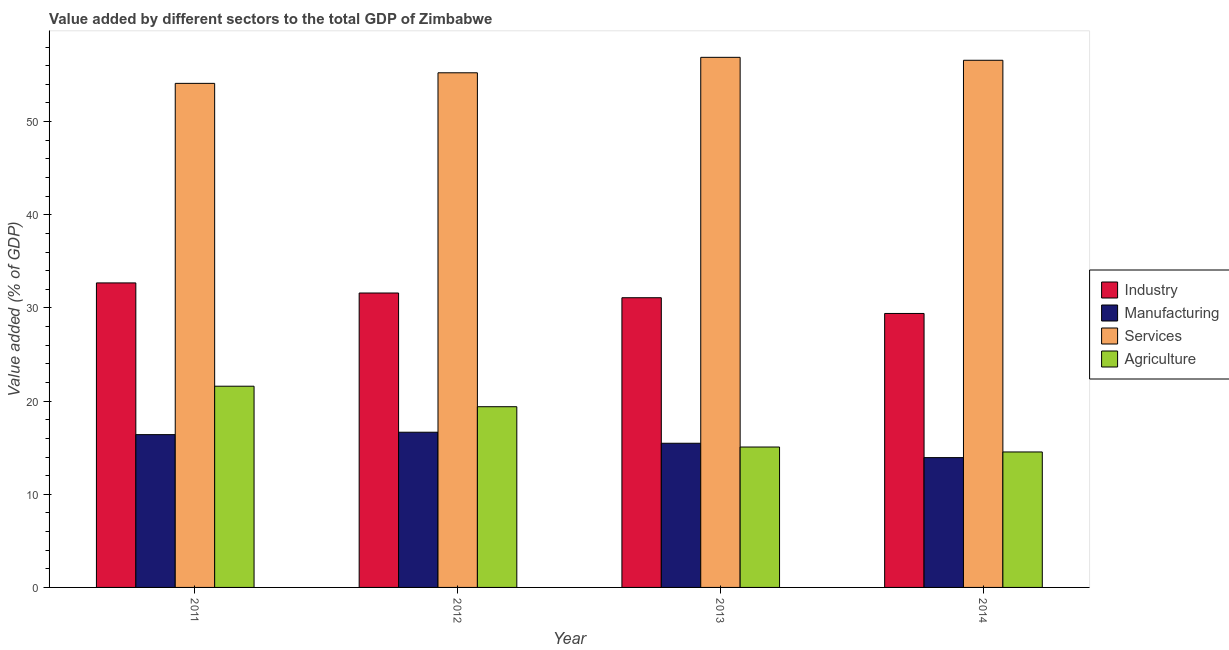How many different coloured bars are there?
Your answer should be very brief. 4. How many groups of bars are there?
Your answer should be compact. 4. Are the number of bars per tick equal to the number of legend labels?
Your answer should be compact. Yes. How many bars are there on the 1st tick from the left?
Ensure brevity in your answer.  4. How many bars are there on the 1st tick from the right?
Make the answer very short. 4. What is the label of the 1st group of bars from the left?
Make the answer very short. 2011. What is the value added by manufacturing sector in 2011?
Your answer should be very brief. 16.4. Across all years, what is the maximum value added by manufacturing sector?
Offer a very short reply. 16.66. Across all years, what is the minimum value added by manufacturing sector?
Provide a short and direct response. 13.93. In which year was the value added by manufacturing sector maximum?
Your response must be concise. 2012. In which year was the value added by services sector minimum?
Your answer should be very brief. 2011. What is the total value added by agricultural sector in the graph?
Provide a short and direct response. 70.61. What is the difference between the value added by industrial sector in 2012 and that in 2013?
Keep it short and to the point. 0.51. What is the difference between the value added by manufacturing sector in 2014 and the value added by agricultural sector in 2011?
Give a very brief answer. -2.47. What is the average value added by agricultural sector per year?
Provide a succinct answer. 17.65. In the year 2013, what is the difference between the value added by services sector and value added by manufacturing sector?
Your response must be concise. 0. What is the ratio of the value added by manufacturing sector in 2011 to that in 2013?
Provide a succinct answer. 1.06. Is the value added by services sector in 2011 less than that in 2013?
Make the answer very short. Yes. Is the difference between the value added by industrial sector in 2012 and 2014 greater than the difference between the value added by services sector in 2012 and 2014?
Provide a short and direct response. No. What is the difference between the highest and the second highest value added by industrial sector?
Your answer should be very brief. 1.08. What is the difference between the highest and the lowest value added by manufacturing sector?
Your answer should be compact. 2.73. What does the 2nd bar from the left in 2011 represents?
Provide a succinct answer. Manufacturing. What does the 4th bar from the right in 2012 represents?
Your response must be concise. Industry. Is it the case that in every year, the sum of the value added by industrial sector and value added by manufacturing sector is greater than the value added by services sector?
Give a very brief answer. No. Are the values on the major ticks of Y-axis written in scientific E-notation?
Keep it short and to the point. No. Where does the legend appear in the graph?
Offer a very short reply. Center right. How many legend labels are there?
Ensure brevity in your answer.  4. What is the title of the graph?
Give a very brief answer. Value added by different sectors to the total GDP of Zimbabwe. Does "Custom duties" appear as one of the legend labels in the graph?
Your response must be concise. No. What is the label or title of the Y-axis?
Provide a succinct answer. Value added (% of GDP). What is the Value added (% of GDP) in Industry in 2011?
Offer a terse response. 32.69. What is the Value added (% of GDP) of Manufacturing in 2011?
Provide a succinct answer. 16.4. What is the Value added (% of GDP) of Services in 2011?
Provide a short and direct response. 54.11. What is the Value added (% of GDP) in Agriculture in 2011?
Make the answer very short. 21.6. What is the Value added (% of GDP) in Industry in 2012?
Provide a succinct answer. 31.6. What is the Value added (% of GDP) of Manufacturing in 2012?
Your answer should be compact. 16.66. What is the Value added (% of GDP) in Services in 2012?
Ensure brevity in your answer.  55.24. What is the Value added (% of GDP) in Agriculture in 2012?
Offer a terse response. 19.4. What is the Value added (% of GDP) in Industry in 2013?
Keep it short and to the point. 31.1. What is the Value added (% of GDP) of Manufacturing in 2013?
Give a very brief answer. 15.48. What is the Value added (% of GDP) of Services in 2013?
Your response must be concise. 56.9. What is the Value added (% of GDP) of Agriculture in 2013?
Offer a very short reply. 15.07. What is the Value added (% of GDP) in Industry in 2014?
Keep it short and to the point. 29.41. What is the Value added (% of GDP) in Manufacturing in 2014?
Offer a very short reply. 13.93. What is the Value added (% of GDP) of Services in 2014?
Make the answer very short. 56.59. What is the Value added (% of GDP) of Agriculture in 2014?
Make the answer very short. 14.54. Across all years, what is the maximum Value added (% of GDP) in Industry?
Your answer should be compact. 32.69. Across all years, what is the maximum Value added (% of GDP) of Manufacturing?
Your response must be concise. 16.66. Across all years, what is the maximum Value added (% of GDP) of Services?
Give a very brief answer. 56.9. Across all years, what is the maximum Value added (% of GDP) in Agriculture?
Make the answer very short. 21.6. Across all years, what is the minimum Value added (% of GDP) of Industry?
Offer a very short reply. 29.41. Across all years, what is the minimum Value added (% of GDP) of Manufacturing?
Offer a terse response. 13.93. Across all years, what is the minimum Value added (% of GDP) in Services?
Offer a terse response. 54.11. Across all years, what is the minimum Value added (% of GDP) of Agriculture?
Your response must be concise. 14.54. What is the total Value added (% of GDP) in Industry in the graph?
Provide a succinct answer. 124.79. What is the total Value added (% of GDP) in Manufacturing in the graph?
Provide a succinct answer. 62.47. What is the total Value added (% of GDP) in Services in the graph?
Ensure brevity in your answer.  222.84. What is the total Value added (% of GDP) in Agriculture in the graph?
Ensure brevity in your answer.  70.61. What is the difference between the Value added (% of GDP) in Industry in 2011 and that in 2012?
Your response must be concise. 1.08. What is the difference between the Value added (% of GDP) of Manufacturing in 2011 and that in 2012?
Your response must be concise. -0.26. What is the difference between the Value added (% of GDP) in Services in 2011 and that in 2012?
Give a very brief answer. -1.13. What is the difference between the Value added (% of GDP) in Agriculture in 2011 and that in 2012?
Your response must be concise. 2.2. What is the difference between the Value added (% of GDP) of Industry in 2011 and that in 2013?
Give a very brief answer. 1.59. What is the difference between the Value added (% of GDP) in Manufacturing in 2011 and that in 2013?
Offer a very short reply. 0.93. What is the difference between the Value added (% of GDP) in Services in 2011 and that in 2013?
Your response must be concise. -2.79. What is the difference between the Value added (% of GDP) in Agriculture in 2011 and that in 2013?
Ensure brevity in your answer.  6.53. What is the difference between the Value added (% of GDP) of Industry in 2011 and that in 2014?
Your response must be concise. 3.28. What is the difference between the Value added (% of GDP) of Manufacturing in 2011 and that in 2014?
Ensure brevity in your answer.  2.47. What is the difference between the Value added (% of GDP) of Services in 2011 and that in 2014?
Offer a very short reply. -2.48. What is the difference between the Value added (% of GDP) of Agriculture in 2011 and that in 2014?
Make the answer very short. 7.06. What is the difference between the Value added (% of GDP) in Industry in 2012 and that in 2013?
Your answer should be very brief. 0.51. What is the difference between the Value added (% of GDP) of Manufacturing in 2012 and that in 2013?
Your answer should be compact. 1.18. What is the difference between the Value added (% of GDP) in Services in 2012 and that in 2013?
Your answer should be very brief. -1.66. What is the difference between the Value added (% of GDP) in Agriculture in 2012 and that in 2013?
Provide a succinct answer. 4.33. What is the difference between the Value added (% of GDP) in Industry in 2012 and that in 2014?
Your answer should be compact. 2.2. What is the difference between the Value added (% of GDP) in Manufacturing in 2012 and that in 2014?
Your answer should be very brief. 2.73. What is the difference between the Value added (% of GDP) of Services in 2012 and that in 2014?
Make the answer very short. -1.34. What is the difference between the Value added (% of GDP) in Agriculture in 2012 and that in 2014?
Provide a short and direct response. 4.86. What is the difference between the Value added (% of GDP) in Industry in 2013 and that in 2014?
Provide a short and direct response. 1.69. What is the difference between the Value added (% of GDP) of Manufacturing in 2013 and that in 2014?
Give a very brief answer. 1.54. What is the difference between the Value added (% of GDP) of Services in 2013 and that in 2014?
Offer a terse response. 0.32. What is the difference between the Value added (% of GDP) of Agriculture in 2013 and that in 2014?
Offer a terse response. 0.53. What is the difference between the Value added (% of GDP) of Industry in 2011 and the Value added (% of GDP) of Manufacturing in 2012?
Offer a very short reply. 16.03. What is the difference between the Value added (% of GDP) of Industry in 2011 and the Value added (% of GDP) of Services in 2012?
Keep it short and to the point. -22.56. What is the difference between the Value added (% of GDP) of Industry in 2011 and the Value added (% of GDP) of Agriculture in 2012?
Offer a very short reply. 13.29. What is the difference between the Value added (% of GDP) in Manufacturing in 2011 and the Value added (% of GDP) in Services in 2012?
Your answer should be very brief. -38.84. What is the difference between the Value added (% of GDP) of Manufacturing in 2011 and the Value added (% of GDP) of Agriculture in 2012?
Give a very brief answer. -3. What is the difference between the Value added (% of GDP) of Services in 2011 and the Value added (% of GDP) of Agriculture in 2012?
Keep it short and to the point. 34.71. What is the difference between the Value added (% of GDP) in Industry in 2011 and the Value added (% of GDP) in Manufacturing in 2013?
Offer a terse response. 17.21. What is the difference between the Value added (% of GDP) in Industry in 2011 and the Value added (% of GDP) in Services in 2013?
Provide a succinct answer. -24.21. What is the difference between the Value added (% of GDP) in Industry in 2011 and the Value added (% of GDP) in Agriculture in 2013?
Make the answer very short. 17.61. What is the difference between the Value added (% of GDP) in Manufacturing in 2011 and the Value added (% of GDP) in Services in 2013?
Offer a very short reply. -40.5. What is the difference between the Value added (% of GDP) of Manufacturing in 2011 and the Value added (% of GDP) of Agriculture in 2013?
Provide a succinct answer. 1.33. What is the difference between the Value added (% of GDP) of Services in 2011 and the Value added (% of GDP) of Agriculture in 2013?
Your answer should be compact. 39.04. What is the difference between the Value added (% of GDP) in Industry in 2011 and the Value added (% of GDP) in Manufacturing in 2014?
Your answer should be very brief. 18.75. What is the difference between the Value added (% of GDP) of Industry in 2011 and the Value added (% of GDP) of Services in 2014?
Your answer should be compact. -23.9. What is the difference between the Value added (% of GDP) in Industry in 2011 and the Value added (% of GDP) in Agriculture in 2014?
Your answer should be very brief. 18.15. What is the difference between the Value added (% of GDP) in Manufacturing in 2011 and the Value added (% of GDP) in Services in 2014?
Ensure brevity in your answer.  -40.18. What is the difference between the Value added (% of GDP) of Manufacturing in 2011 and the Value added (% of GDP) of Agriculture in 2014?
Provide a succinct answer. 1.86. What is the difference between the Value added (% of GDP) in Services in 2011 and the Value added (% of GDP) in Agriculture in 2014?
Keep it short and to the point. 39.57. What is the difference between the Value added (% of GDP) in Industry in 2012 and the Value added (% of GDP) in Manufacturing in 2013?
Ensure brevity in your answer.  16.13. What is the difference between the Value added (% of GDP) of Industry in 2012 and the Value added (% of GDP) of Services in 2013?
Offer a very short reply. -25.3. What is the difference between the Value added (% of GDP) in Industry in 2012 and the Value added (% of GDP) in Agriculture in 2013?
Provide a short and direct response. 16.53. What is the difference between the Value added (% of GDP) in Manufacturing in 2012 and the Value added (% of GDP) in Services in 2013?
Your answer should be compact. -40.24. What is the difference between the Value added (% of GDP) in Manufacturing in 2012 and the Value added (% of GDP) in Agriculture in 2013?
Provide a succinct answer. 1.59. What is the difference between the Value added (% of GDP) in Services in 2012 and the Value added (% of GDP) in Agriculture in 2013?
Offer a terse response. 40.17. What is the difference between the Value added (% of GDP) of Industry in 2012 and the Value added (% of GDP) of Manufacturing in 2014?
Your answer should be very brief. 17.67. What is the difference between the Value added (% of GDP) of Industry in 2012 and the Value added (% of GDP) of Services in 2014?
Your answer should be compact. -24.98. What is the difference between the Value added (% of GDP) in Industry in 2012 and the Value added (% of GDP) in Agriculture in 2014?
Ensure brevity in your answer.  17.06. What is the difference between the Value added (% of GDP) of Manufacturing in 2012 and the Value added (% of GDP) of Services in 2014?
Keep it short and to the point. -39.93. What is the difference between the Value added (% of GDP) of Manufacturing in 2012 and the Value added (% of GDP) of Agriculture in 2014?
Offer a terse response. 2.12. What is the difference between the Value added (% of GDP) of Services in 2012 and the Value added (% of GDP) of Agriculture in 2014?
Make the answer very short. 40.7. What is the difference between the Value added (% of GDP) in Industry in 2013 and the Value added (% of GDP) in Manufacturing in 2014?
Your answer should be compact. 17.16. What is the difference between the Value added (% of GDP) of Industry in 2013 and the Value added (% of GDP) of Services in 2014?
Offer a terse response. -25.49. What is the difference between the Value added (% of GDP) in Industry in 2013 and the Value added (% of GDP) in Agriculture in 2014?
Your response must be concise. 16.56. What is the difference between the Value added (% of GDP) in Manufacturing in 2013 and the Value added (% of GDP) in Services in 2014?
Provide a succinct answer. -41.11. What is the difference between the Value added (% of GDP) in Manufacturing in 2013 and the Value added (% of GDP) in Agriculture in 2014?
Provide a short and direct response. 0.93. What is the difference between the Value added (% of GDP) of Services in 2013 and the Value added (% of GDP) of Agriculture in 2014?
Your answer should be very brief. 42.36. What is the average Value added (% of GDP) of Industry per year?
Provide a short and direct response. 31.2. What is the average Value added (% of GDP) of Manufacturing per year?
Offer a terse response. 15.62. What is the average Value added (% of GDP) in Services per year?
Offer a terse response. 55.71. What is the average Value added (% of GDP) in Agriculture per year?
Make the answer very short. 17.65. In the year 2011, what is the difference between the Value added (% of GDP) in Industry and Value added (% of GDP) in Manufacturing?
Provide a short and direct response. 16.29. In the year 2011, what is the difference between the Value added (% of GDP) of Industry and Value added (% of GDP) of Services?
Keep it short and to the point. -21.42. In the year 2011, what is the difference between the Value added (% of GDP) of Industry and Value added (% of GDP) of Agriculture?
Offer a terse response. 11.09. In the year 2011, what is the difference between the Value added (% of GDP) of Manufacturing and Value added (% of GDP) of Services?
Your answer should be compact. -37.71. In the year 2011, what is the difference between the Value added (% of GDP) of Manufacturing and Value added (% of GDP) of Agriculture?
Your answer should be very brief. -5.2. In the year 2011, what is the difference between the Value added (% of GDP) of Services and Value added (% of GDP) of Agriculture?
Offer a terse response. 32.51. In the year 2012, what is the difference between the Value added (% of GDP) of Industry and Value added (% of GDP) of Manufacturing?
Give a very brief answer. 14.95. In the year 2012, what is the difference between the Value added (% of GDP) in Industry and Value added (% of GDP) in Services?
Keep it short and to the point. -23.64. In the year 2012, what is the difference between the Value added (% of GDP) of Industry and Value added (% of GDP) of Agriculture?
Keep it short and to the point. 12.21. In the year 2012, what is the difference between the Value added (% of GDP) in Manufacturing and Value added (% of GDP) in Services?
Provide a succinct answer. -38.58. In the year 2012, what is the difference between the Value added (% of GDP) of Manufacturing and Value added (% of GDP) of Agriculture?
Your response must be concise. -2.74. In the year 2012, what is the difference between the Value added (% of GDP) of Services and Value added (% of GDP) of Agriculture?
Ensure brevity in your answer.  35.84. In the year 2013, what is the difference between the Value added (% of GDP) of Industry and Value added (% of GDP) of Manufacturing?
Make the answer very short. 15.62. In the year 2013, what is the difference between the Value added (% of GDP) in Industry and Value added (% of GDP) in Services?
Your answer should be very brief. -25.8. In the year 2013, what is the difference between the Value added (% of GDP) of Industry and Value added (% of GDP) of Agriculture?
Your answer should be compact. 16.03. In the year 2013, what is the difference between the Value added (% of GDP) in Manufacturing and Value added (% of GDP) in Services?
Make the answer very short. -41.43. In the year 2013, what is the difference between the Value added (% of GDP) of Manufacturing and Value added (% of GDP) of Agriculture?
Give a very brief answer. 0.4. In the year 2013, what is the difference between the Value added (% of GDP) of Services and Value added (% of GDP) of Agriculture?
Provide a short and direct response. 41.83. In the year 2014, what is the difference between the Value added (% of GDP) in Industry and Value added (% of GDP) in Manufacturing?
Provide a succinct answer. 15.47. In the year 2014, what is the difference between the Value added (% of GDP) in Industry and Value added (% of GDP) in Services?
Keep it short and to the point. -27.18. In the year 2014, what is the difference between the Value added (% of GDP) in Industry and Value added (% of GDP) in Agriculture?
Provide a succinct answer. 14.87. In the year 2014, what is the difference between the Value added (% of GDP) of Manufacturing and Value added (% of GDP) of Services?
Offer a terse response. -42.65. In the year 2014, what is the difference between the Value added (% of GDP) of Manufacturing and Value added (% of GDP) of Agriculture?
Keep it short and to the point. -0.61. In the year 2014, what is the difference between the Value added (% of GDP) in Services and Value added (% of GDP) in Agriculture?
Provide a succinct answer. 42.04. What is the ratio of the Value added (% of GDP) in Industry in 2011 to that in 2012?
Make the answer very short. 1.03. What is the ratio of the Value added (% of GDP) in Manufacturing in 2011 to that in 2012?
Your answer should be very brief. 0.98. What is the ratio of the Value added (% of GDP) of Services in 2011 to that in 2012?
Your response must be concise. 0.98. What is the ratio of the Value added (% of GDP) of Agriculture in 2011 to that in 2012?
Offer a terse response. 1.11. What is the ratio of the Value added (% of GDP) in Industry in 2011 to that in 2013?
Your answer should be very brief. 1.05. What is the ratio of the Value added (% of GDP) of Manufacturing in 2011 to that in 2013?
Your answer should be very brief. 1.06. What is the ratio of the Value added (% of GDP) in Services in 2011 to that in 2013?
Make the answer very short. 0.95. What is the ratio of the Value added (% of GDP) in Agriculture in 2011 to that in 2013?
Keep it short and to the point. 1.43. What is the ratio of the Value added (% of GDP) of Industry in 2011 to that in 2014?
Offer a very short reply. 1.11. What is the ratio of the Value added (% of GDP) in Manufacturing in 2011 to that in 2014?
Make the answer very short. 1.18. What is the ratio of the Value added (% of GDP) of Services in 2011 to that in 2014?
Provide a succinct answer. 0.96. What is the ratio of the Value added (% of GDP) in Agriculture in 2011 to that in 2014?
Provide a succinct answer. 1.49. What is the ratio of the Value added (% of GDP) in Industry in 2012 to that in 2013?
Offer a terse response. 1.02. What is the ratio of the Value added (% of GDP) of Manufacturing in 2012 to that in 2013?
Keep it short and to the point. 1.08. What is the ratio of the Value added (% of GDP) in Services in 2012 to that in 2013?
Your answer should be compact. 0.97. What is the ratio of the Value added (% of GDP) in Agriculture in 2012 to that in 2013?
Ensure brevity in your answer.  1.29. What is the ratio of the Value added (% of GDP) of Industry in 2012 to that in 2014?
Make the answer very short. 1.07. What is the ratio of the Value added (% of GDP) in Manufacturing in 2012 to that in 2014?
Make the answer very short. 1.2. What is the ratio of the Value added (% of GDP) of Services in 2012 to that in 2014?
Give a very brief answer. 0.98. What is the ratio of the Value added (% of GDP) of Agriculture in 2012 to that in 2014?
Offer a very short reply. 1.33. What is the ratio of the Value added (% of GDP) of Industry in 2013 to that in 2014?
Provide a succinct answer. 1.06. What is the ratio of the Value added (% of GDP) of Manufacturing in 2013 to that in 2014?
Offer a very short reply. 1.11. What is the ratio of the Value added (% of GDP) of Services in 2013 to that in 2014?
Ensure brevity in your answer.  1.01. What is the ratio of the Value added (% of GDP) of Agriculture in 2013 to that in 2014?
Keep it short and to the point. 1.04. What is the difference between the highest and the second highest Value added (% of GDP) in Industry?
Give a very brief answer. 1.08. What is the difference between the highest and the second highest Value added (% of GDP) of Manufacturing?
Make the answer very short. 0.26. What is the difference between the highest and the second highest Value added (% of GDP) in Services?
Give a very brief answer. 0.32. What is the difference between the highest and the second highest Value added (% of GDP) in Agriculture?
Offer a terse response. 2.2. What is the difference between the highest and the lowest Value added (% of GDP) of Industry?
Your answer should be very brief. 3.28. What is the difference between the highest and the lowest Value added (% of GDP) in Manufacturing?
Your answer should be compact. 2.73. What is the difference between the highest and the lowest Value added (% of GDP) of Services?
Your answer should be very brief. 2.79. What is the difference between the highest and the lowest Value added (% of GDP) in Agriculture?
Your answer should be very brief. 7.06. 